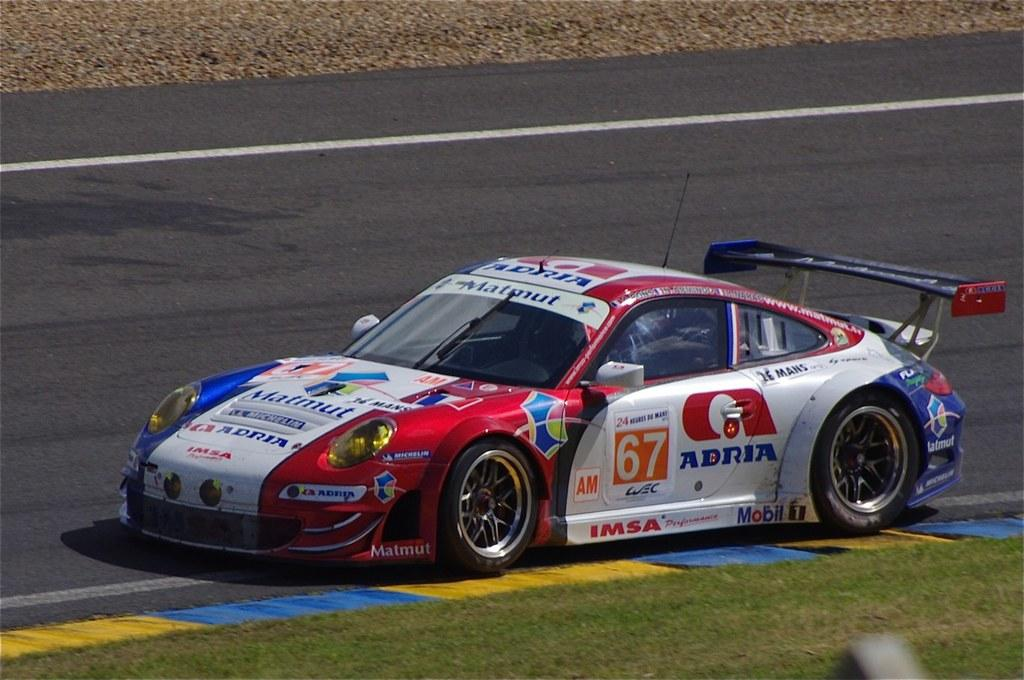What is on the road in the image? There is a vehicle on the road in the image. What else can be seen beside the road? There is an object beside the road. What type of vegetation is visible in the image? Grass is visible in the image. How many toothbrushes are visible in the image? There are no toothbrushes present in the image. 